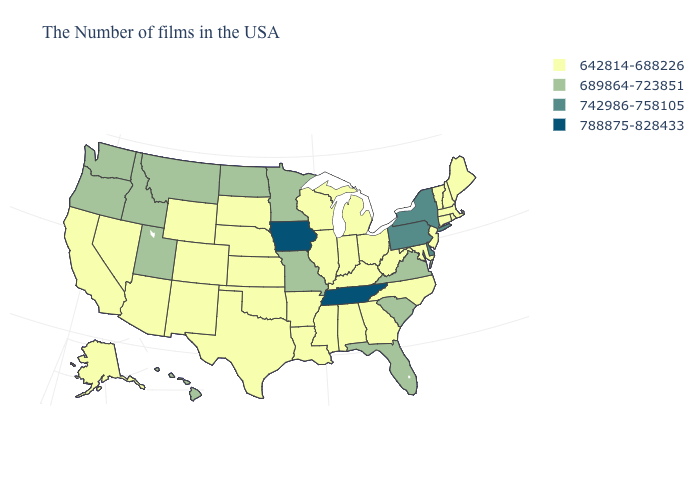What is the value of Massachusetts?
Answer briefly. 642814-688226. What is the value of New York?
Be succinct. 742986-758105. Name the states that have a value in the range 742986-758105?
Concise answer only. New York, Delaware, Pennsylvania. Name the states that have a value in the range 642814-688226?
Write a very short answer. Maine, Massachusetts, Rhode Island, New Hampshire, Vermont, Connecticut, New Jersey, Maryland, North Carolina, West Virginia, Ohio, Georgia, Michigan, Kentucky, Indiana, Alabama, Wisconsin, Illinois, Mississippi, Louisiana, Arkansas, Kansas, Nebraska, Oklahoma, Texas, South Dakota, Wyoming, Colorado, New Mexico, Arizona, Nevada, California, Alaska. Name the states that have a value in the range 642814-688226?
Answer briefly. Maine, Massachusetts, Rhode Island, New Hampshire, Vermont, Connecticut, New Jersey, Maryland, North Carolina, West Virginia, Ohio, Georgia, Michigan, Kentucky, Indiana, Alabama, Wisconsin, Illinois, Mississippi, Louisiana, Arkansas, Kansas, Nebraska, Oklahoma, Texas, South Dakota, Wyoming, Colorado, New Mexico, Arizona, Nevada, California, Alaska. What is the highest value in states that border Alabama?
Write a very short answer. 788875-828433. What is the lowest value in the MidWest?
Be succinct. 642814-688226. What is the highest value in states that border West Virginia?
Be succinct. 742986-758105. Is the legend a continuous bar?
Write a very short answer. No. Does Wisconsin have the lowest value in the USA?
Short answer required. Yes. Name the states that have a value in the range 642814-688226?
Short answer required. Maine, Massachusetts, Rhode Island, New Hampshire, Vermont, Connecticut, New Jersey, Maryland, North Carolina, West Virginia, Ohio, Georgia, Michigan, Kentucky, Indiana, Alabama, Wisconsin, Illinois, Mississippi, Louisiana, Arkansas, Kansas, Nebraska, Oklahoma, Texas, South Dakota, Wyoming, Colorado, New Mexico, Arizona, Nevada, California, Alaska. What is the lowest value in the USA?
Keep it brief. 642814-688226. Name the states that have a value in the range 642814-688226?
Answer briefly. Maine, Massachusetts, Rhode Island, New Hampshire, Vermont, Connecticut, New Jersey, Maryland, North Carolina, West Virginia, Ohio, Georgia, Michigan, Kentucky, Indiana, Alabama, Wisconsin, Illinois, Mississippi, Louisiana, Arkansas, Kansas, Nebraska, Oklahoma, Texas, South Dakota, Wyoming, Colorado, New Mexico, Arizona, Nevada, California, Alaska. Which states have the highest value in the USA?
Keep it brief. Tennessee, Iowa. Name the states that have a value in the range 689864-723851?
Give a very brief answer. Virginia, South Carolina, Florida, Missouri, Minnesota, North Dakota, Utah, Montana, Idaho, Washington, Oregon, Hawaii. 